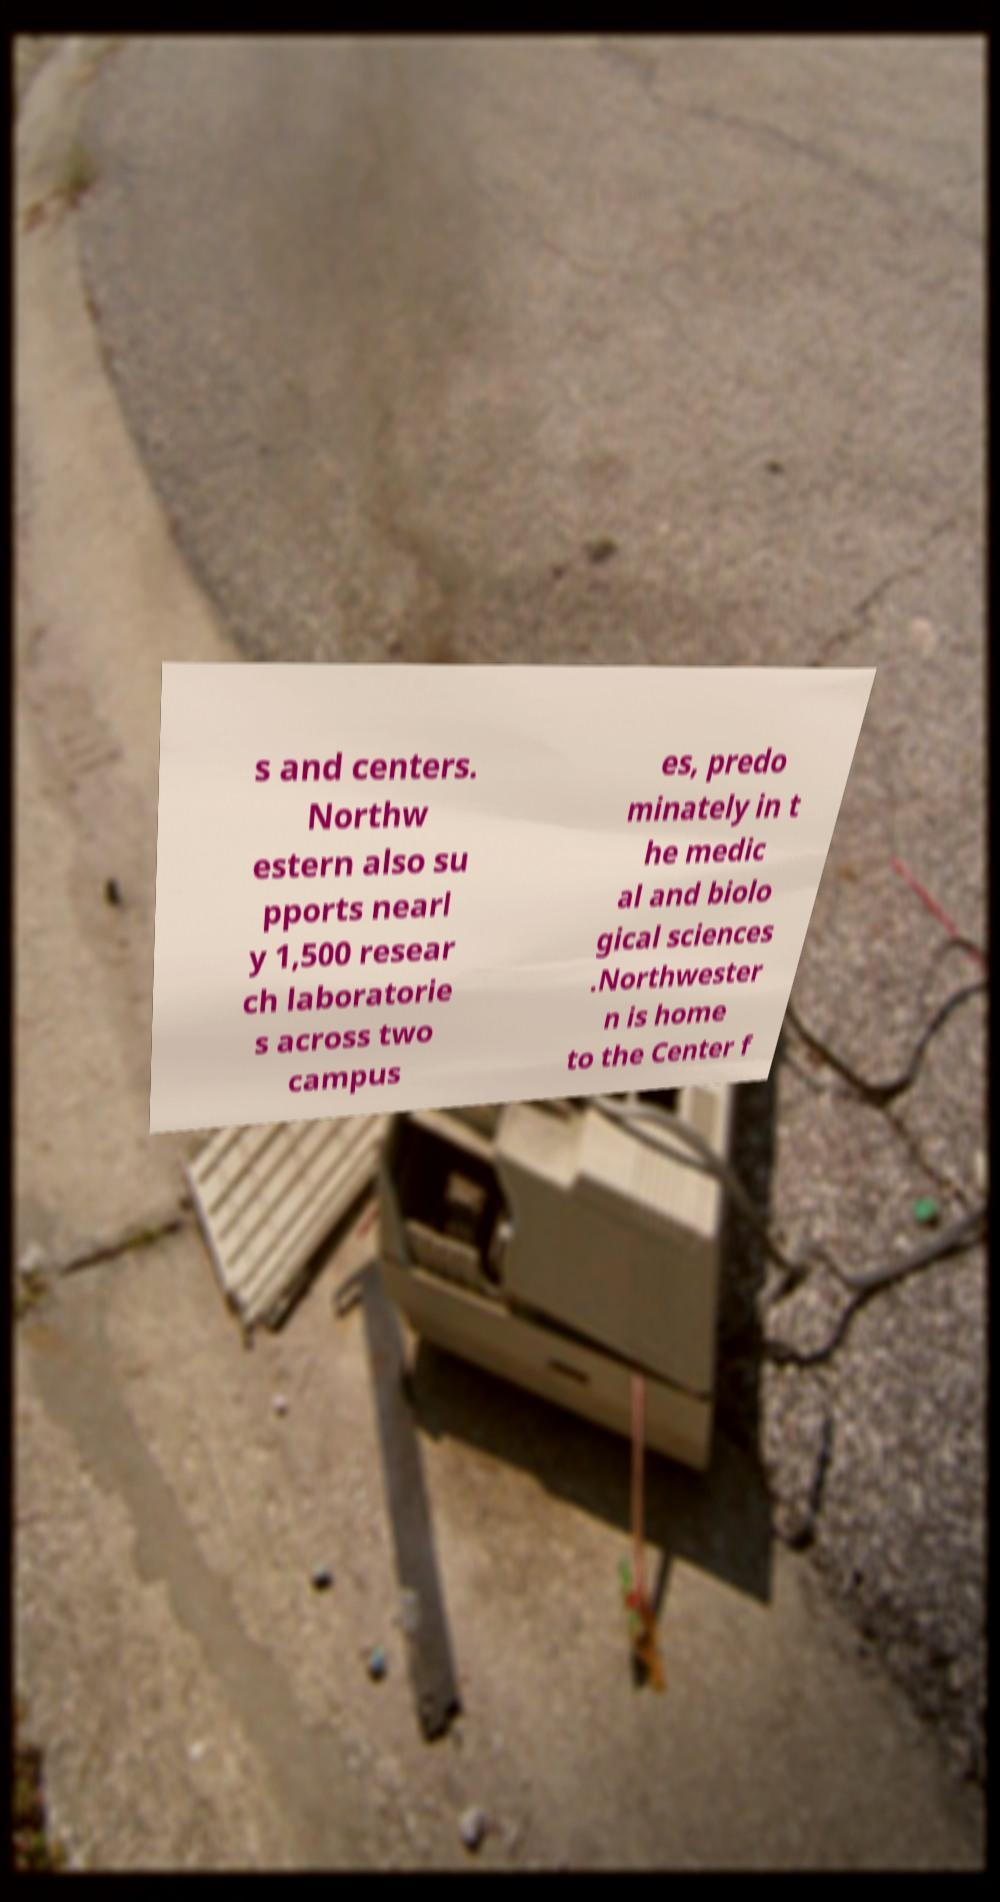Can you accurately transcribe the text from the provided image for me? s and centers. Northw estern also su pports nearl y 1,500 resear ch laboratorie s across two campus es, predo minately in t he medic al and biolo gical sciences .Northwester n is home to the Center f 